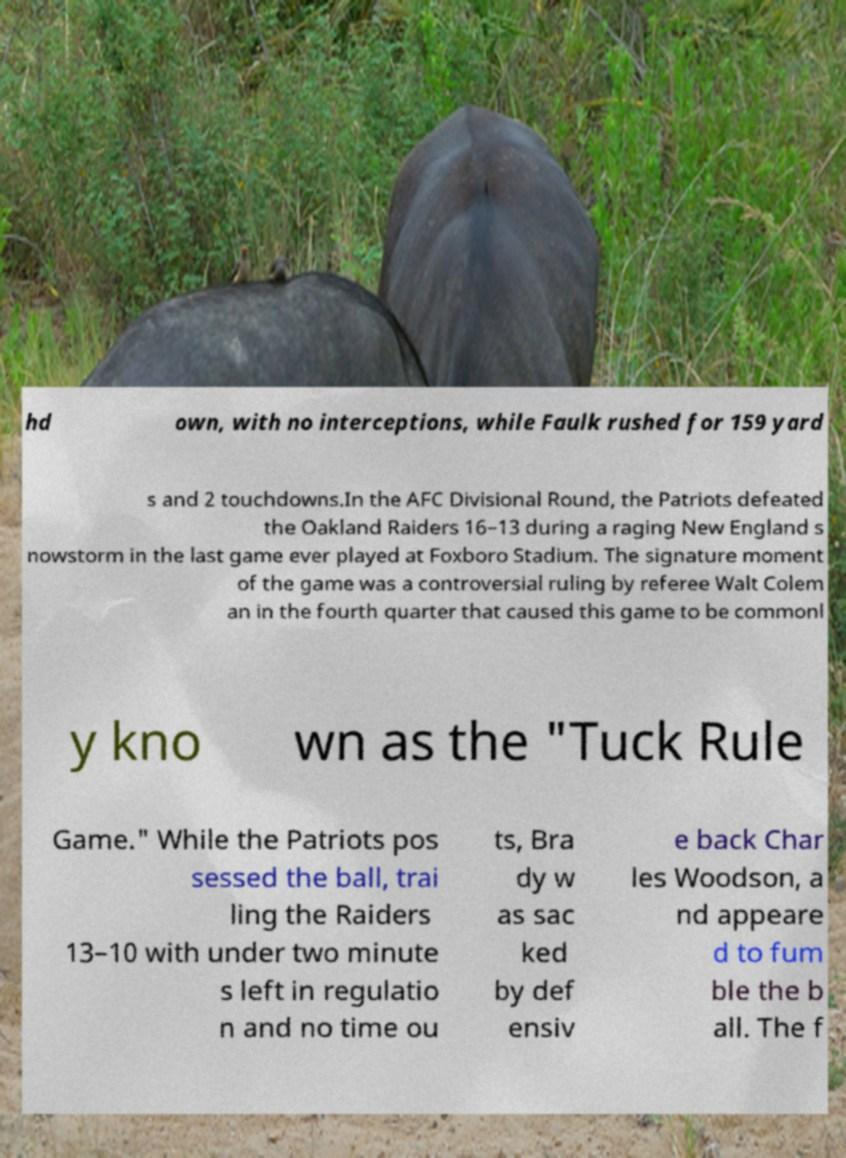Please read and relay the text visible in this image. What does it say? hd own, with no interceptions, while Faulk rushed for 159 yard s and 2 touchdowns.In the AFC Divisional Round, the Patriots defeated the Oakland Raiders 16–13 during a raging New England s nowstorm in the last game ever played at Foxboro Stadium. The signature moment of the game was a controversial ruling by referee Walt Colem an in the fourth quarter that caused this game to be commonl y kno wn as the "Tuck Rule Game." While the Patriots pos sessed the ball, trai ling the Raiders 13–10 with under two minute s left in regulatio n and no time ou ts, Bra dy w as sac ked by def ensiv e back Char les Woodson, a nd appeare d to fum ble the b all. The f 